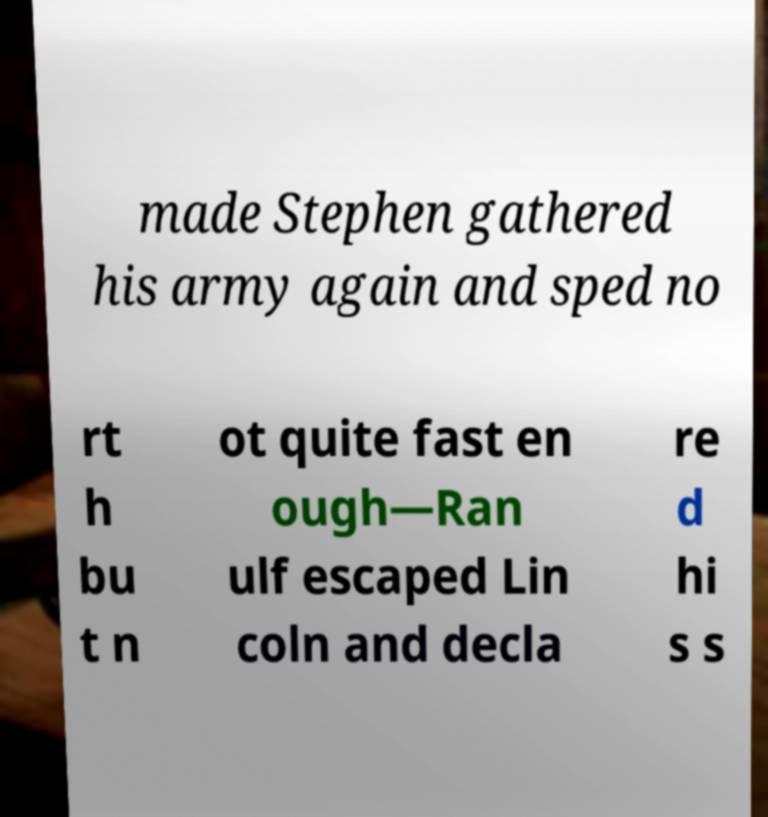Can you accurately transcribe the text from the provided image for me? made Stephen gathered his army again and sped no rt h bu t n ot quite fast en ough—Ran ulf escaped Lin coln and decla re d hi s s 